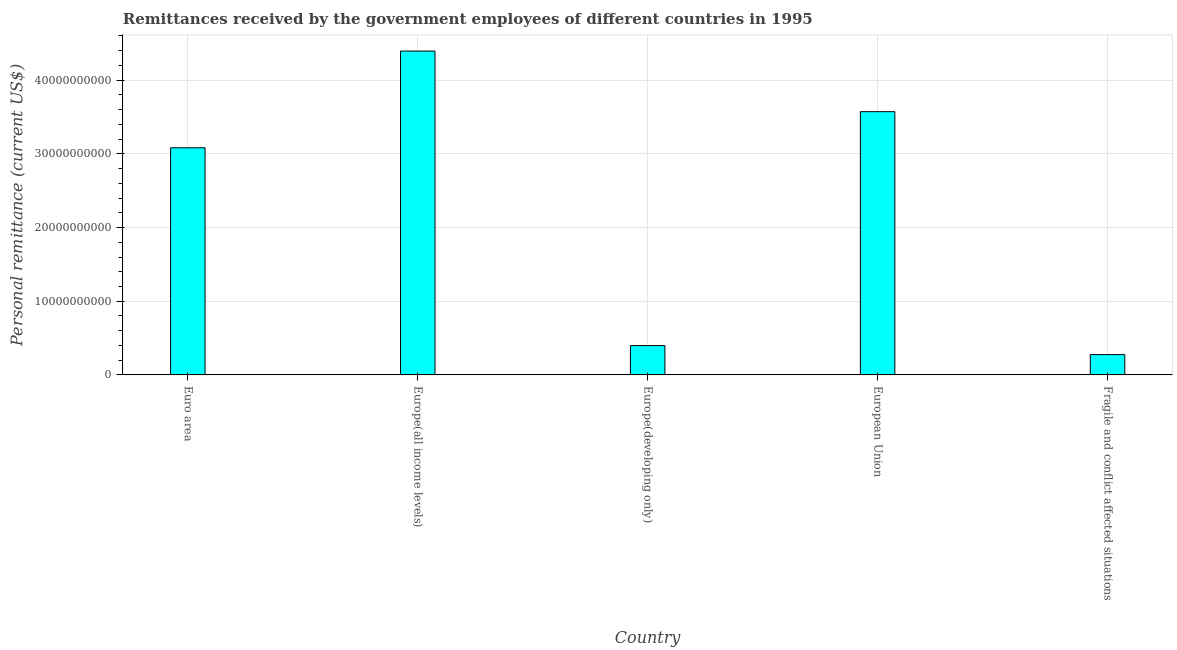What is the title of the graph?
Your answer should be compact. Remittances received by the government employees of different countries in 1995. What is the label or title of the Y-axis?
Keep it short and to the point. Personal remittance (current US$). What is the personal remittances in Europe(developing only)?
Keep it short and to the point. 3.98e+09. Across all countries, what is the maximum personal remittances?
Keep it short and to the point. 4.40e+1. Across all countries, what is the minimum personal remittances?
Keep it short and to the point. 2.76e+09. In which country was the personal remittances maximum?
Your response must be concise. Europe(all income levels). In which country was the personal remittances minimum?
Provide a succinct answer. Fragile and conflict affected situations. What is the sum of the personal remittances?
Offer a very short reply. 1.17e+11. What is the difference between the personal remittances in Euro area and Fragile and conflict affected situations?
Keep it short and to the point. 2.81e+1. What is the average personal remittances per country?
Give a very brief answer. 2.34e+1. What is the median personal remittances?
Offer a terse response. 3.08e+1. What is the ratio of the personal remittances in Europe(all income levels) to that in Fragile and conflict affected situations?
Keep it short and to the point. 15.93. Is the personal remittances in Euro area less than that in Europe(all income levels)?
Your response must be concise. Yes. Is the difference between the personal remittances in Euro area and Europe(all income levels) greater than the difference between any two countries?
Offer a very short reply. No. What is the difference between the highest and the second highest personal remittances?
Ensure brevity in your answer.  8.23e+09. Is the sum of the personal remittances in Europe(developing only) and European Union greater than the maximum personal remittances across all countries?
Give a very brief answer. No. What is the difference between the highest and the lowest personal remittances?
Offer a terse response. 4.12e+1. Are the values on the major ticks of Y-axis written in scientific E-notation?
Ensure brevity in your answer.  No. What is the Personal remittance (current US$) in Euro area?
Keep it short and to the point. 3.08e+1. What is the Personal remittance (current US$) of Europe(all income levels)?
Give a very brief answer. 4.40e+1. What is the Personal remittance (current US$) in Europe(developing only)?
Make the answer very short. 3.98e+09. What is the Personal remittance (current US$) in European Union?
Provide a short and direct response. 3.57e+1. What is the Personal remittance (current US$) in Fragile and conflict affected situations?
Provide a succinct answer. 2.76e+09. What is the difference between the Personal remittance (current US$) in Euro area and Europe(all income levels)?
Make the answer very short. -1.31e+1. What is the difference between the Personal remittance (current US$) in Euro area and Europe(developing only)?
Your response must be concise. 2.68e+1. What is the difference between the Personal remittance (current US$) in Euro area and European Union?
Keep it short and to the point. -4.90e+09. What is the difference between the Personal remittance (current US$) in Euro area and Fragile and conflict affected situations?
Give a very brief answer. 2.81e+1. What is the difference between the Personal remittance (current US$) in Europe(all income levels) and Europe(developing only)?
Give a very brief answer. 4.00e+1. What is the difference between the Personal remittance (current US$) in Europe(all income levels) and European Union?
Keep it short and to the point. 8.23e+09. What is the difference between the Personal remittance (current US$) in Europe(all income levels) and Fragile and conflict affected situations?
Give a very brief answer. 4.12e+1. What is the difference between the Personal remittance (current US$) in Europe(developing only) and European Union?
Your answer should be very brief. -3.17e+1. What is the difference between the Personal remittance (current US$) in Europe(developing only) and Fragile and conflict affected situations?
Provide a succinct answer. 1.22e+09. What is the difference between the Personal remittance (current US$) in European Union and Fragile and conflict affected situations?
Provide a succinct answer. 3.30e+1. What is the ratio of the Personal remittance (current US$) in Euro area to that in Europe(all income levels)?
Ensure brevity in your answer.  0.7. What is the ratio of the Personal remittance (current US$) in Euro area to that in Europe(developing only)?
Your answer should be very brief. 7.75. What is the ratio of the Personal remittance (current US$) in Euro area to that in European Union?
Keep it short and to the point. 0.86. What is the ratio of the Personal remittance (current US$) in Euro area to that in Fragile and conflict affected situations?
Offer a very short reply. 11.17. What is the ratio of the Personal remittance (current US$) in Europe(all income levels) to that in Europe(developing only)?
Your answer should be compact. 11.05. What is the ratio of the Personal remittance (current US$) in Europe(all income levels) to that in European Union?
Provide a short and direct response. 1.23. What is the ratio of the Personal remittance (current US$) in Europe(all income levels) to that in Fragile and conflict affected situations?
Your answer should be very brief. 15.93. What is the ratio of the Personal remittance (current US$) in Europe(developing only) to that in European Union?
Ensure brevity in your answer.  0.11. What is the ratio of the Personal remittance (current US$) in Europe(developing only) to that in Fragile and conflict affected situations?
Keep it short and to the point. 1.44. What is the ratio of the Personal remittance (current US$) in European Union to that in Fragile and conflict affected situations?
Your response must be concise. 12.95. 